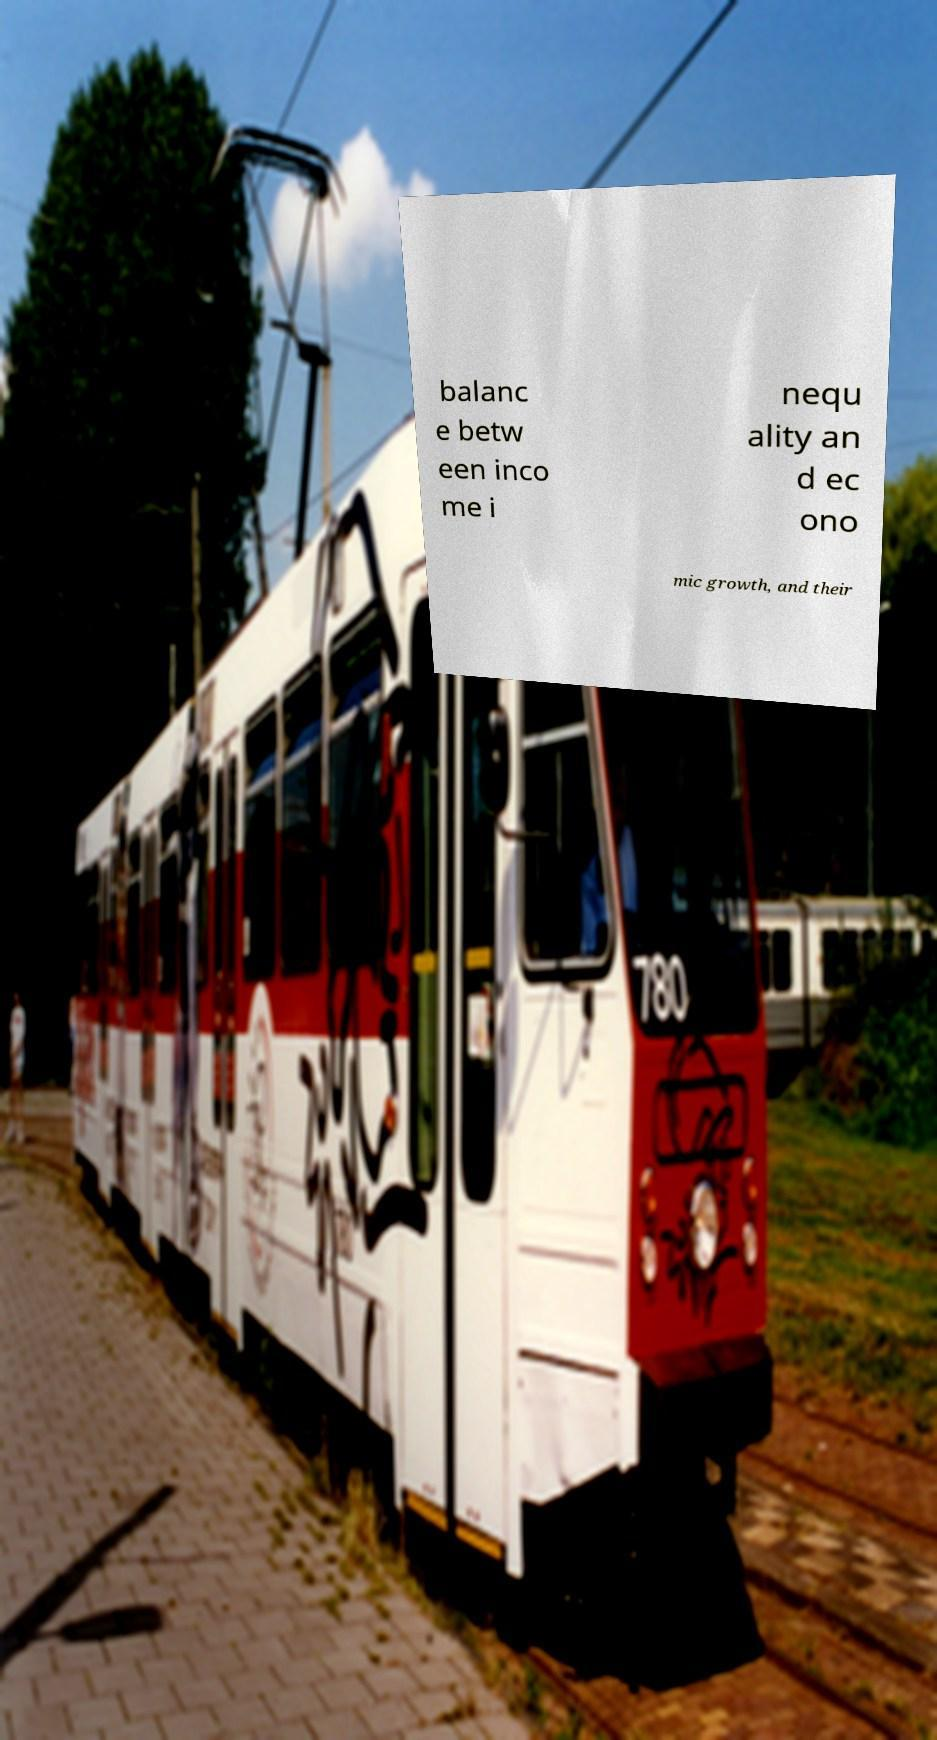Please identify and transcribe the text found in this image. balanc e betw een inco me i nequ ality an d ec ono mic growth, and their 